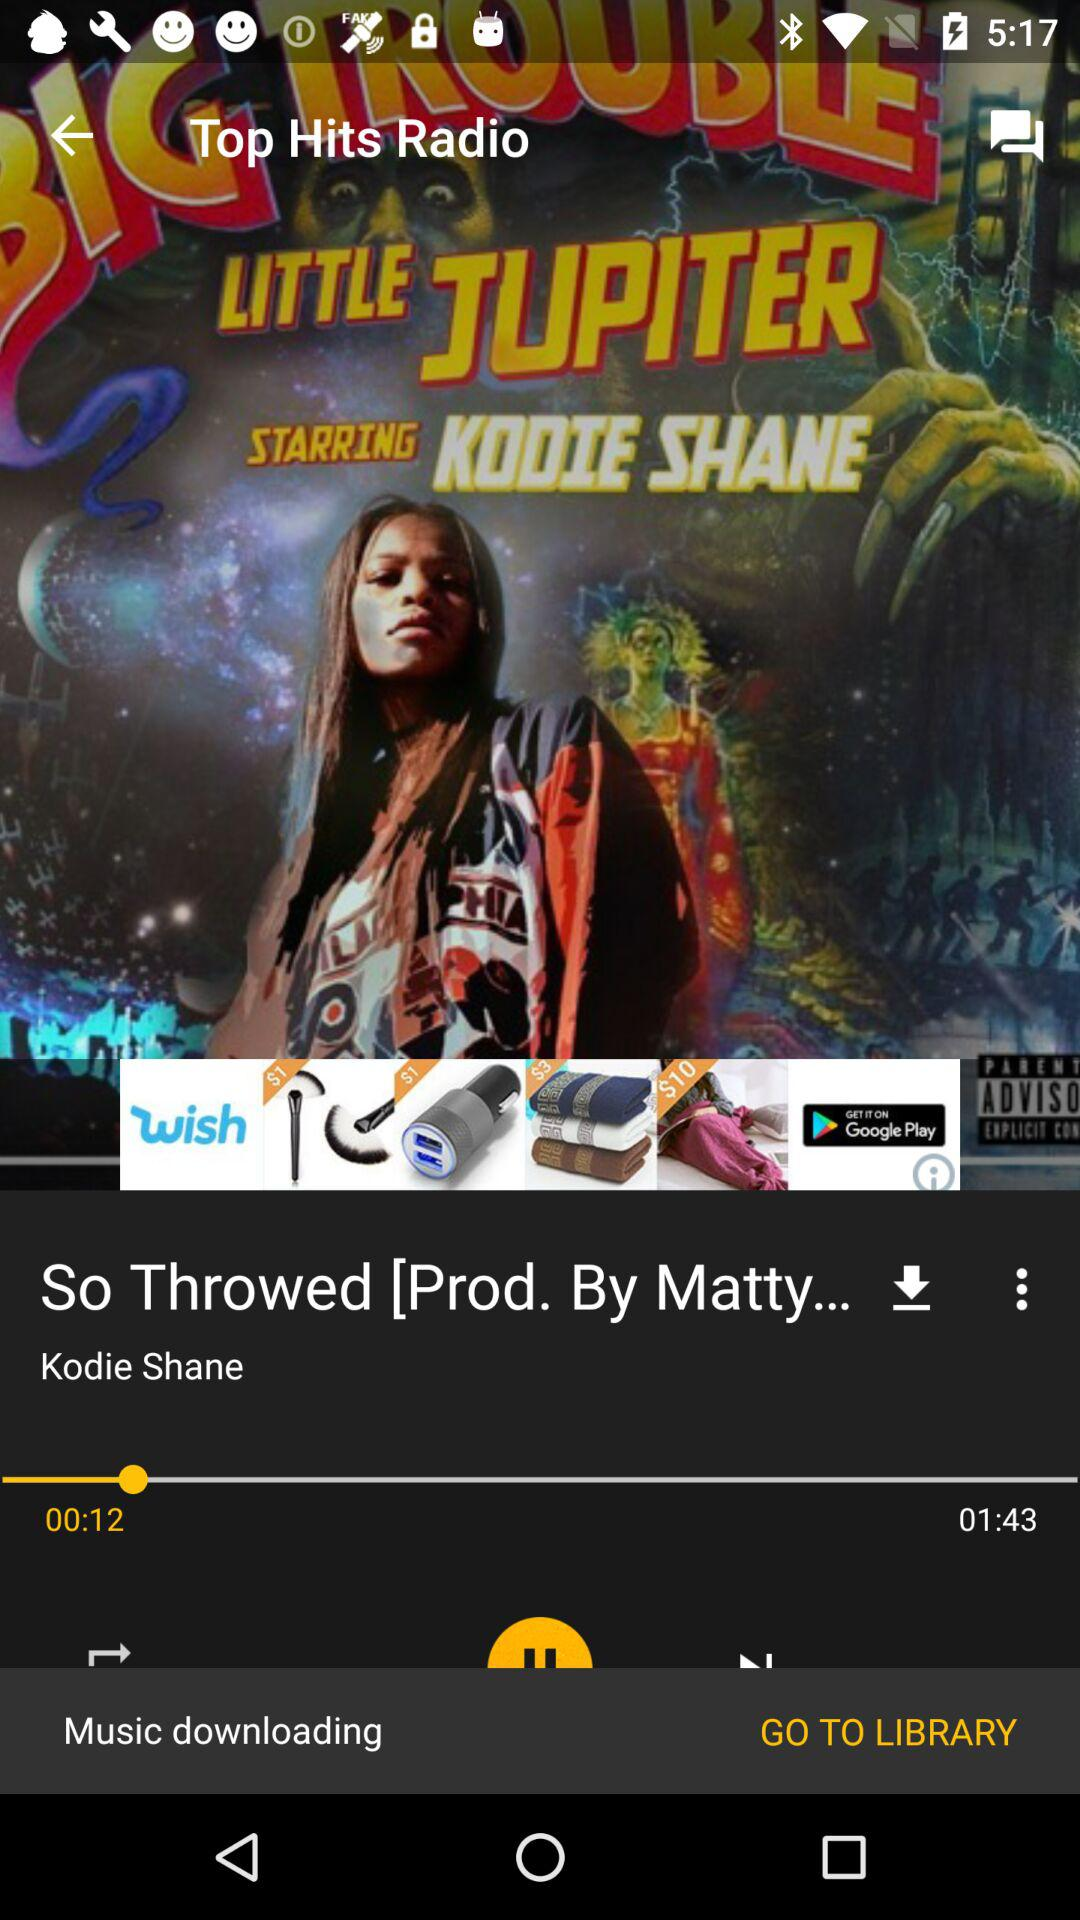How long has the song been playing? The song has been playing for 12 seconds. 